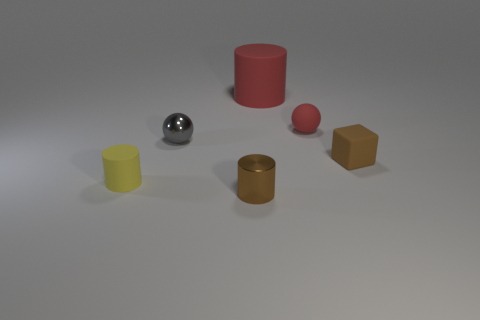Are there any other things that have the same size as the red cylinder?
Offer a terse response. No. Is there anything else that has the same shape as the brown rubber thing?
Ensure brevity in your answer.  No. There is a small thing that is the same color as the big matte cylinder; what material is it?
Ensure brevity in your answer.  Rubber. What number of other rubber objects are the same color as the big matte thing?
Provide a succinct answer. 1. What number of things are either yellow rubber cylinders behind the tiny metal cylinder or small objects that are behind the tiny block?
Your answer should be very brief. 3. There is a shiny object that is behind the small brown block; how many tiny brown metallic things are to the right of it?
Keep it short and to the point. 1. There is a small cylinder that is the same material as the red sphere; what color is it?
Make the answer very short. Yellow. Are there any brown objects of the same size as the yellow cylinder?
Keep it short and to the point. Yes. What is the shape of the brown shiny thing that is the same size as the red rubber sphere?
Give a very brief answer. Cylinder. Is there a small rubber thing of the same shape as the tiny brown shiny object?
Offer a terse response. Yes. 